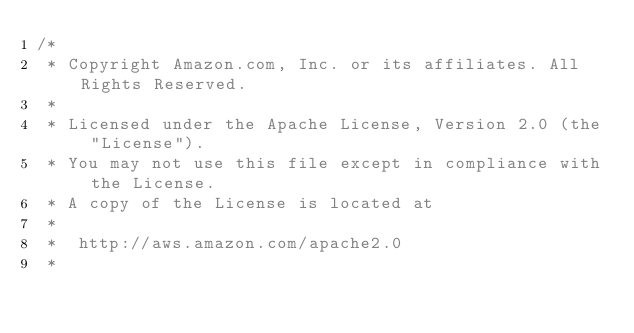Convert code to text. <code><loc_0><loc_0><loc_500><loc_500><_C#_>/*
 * Copyright Amazon.com, Inc. or its affiliates. All Rights Reserved.
 * 
 * Licensed under the Apache License, Version 2.0 (the "License").
 * You may not use this file except in compliance with the License.
 * A copy of the License is located at
 * 
 *  http://aws.amazon.com/apache2.0
 * </code> 